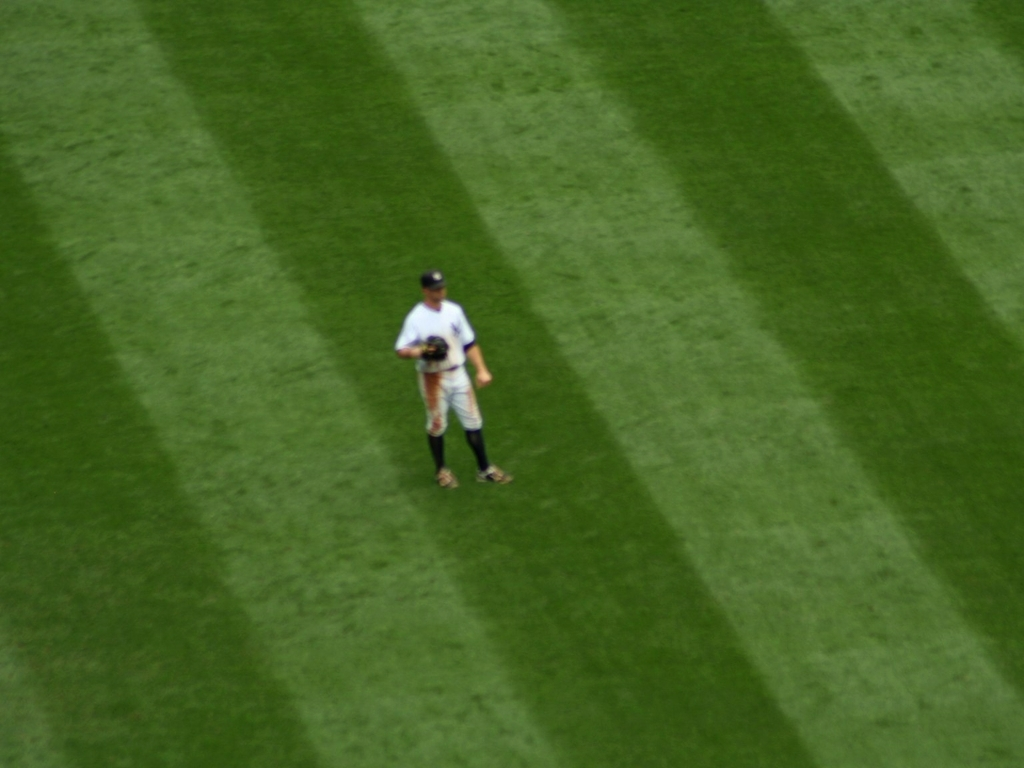What makes it difficult to distinguish the texture of the lawn and person's details? The difficulty in distinguishing the texture of the lawn and person's details is most likely due to low clarity (C). This could be the result of several factors, such as camera focus, motion blur, or atmospheric conditions, all contributing to a reduction in sharpness and detail, making the textures blend into one another and the person's details less distinct. 